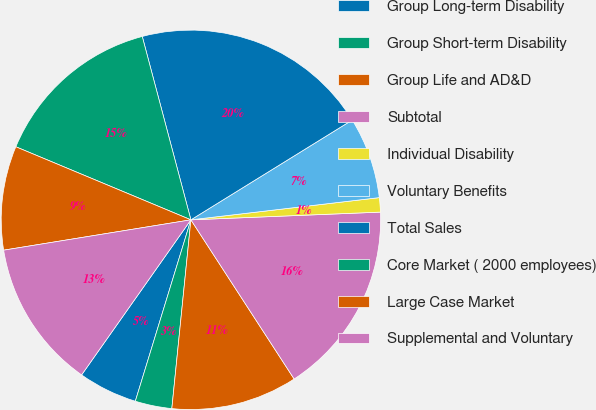Convert chart. <chart><loc_0><loc_0><loc_500><loc_500><pie_chart><fcel>Group Long-term Disability<fcel>Group Short-term Disability<fcel>Group Life and AD&D<fcel>Subtotal<fcel>Individual Disability<fcel>Voluntary Benefits<fcel>Total Sales<fcel>Core Market ( 2000 employees)<fcel>Large Case Market<fcel>Supplemental and Voluntary<nl><fcel>5.04%<fcel>3.13%<fcel>10.76%<fcel>16.49%<fcel>1.22%<fcel>6.95%<fcel>20.31%<fcel>14.58%<fcel>8.85%<fcel>12.67%<nl></chart> 